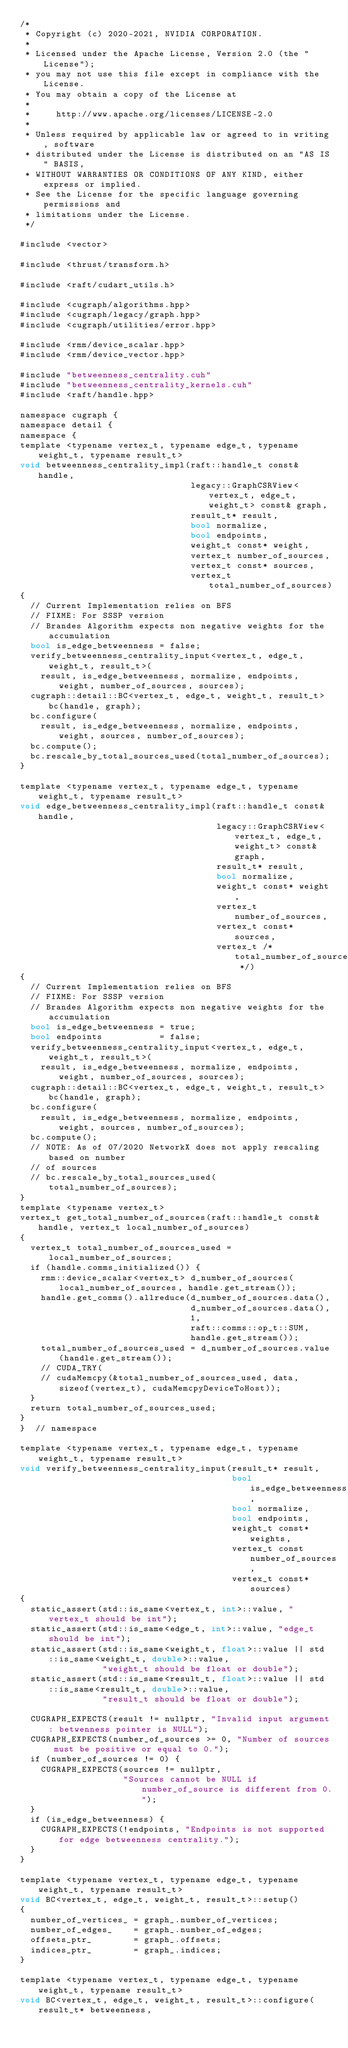Convert code to text. <code><loc_0><loc_0><loc_500><loc_500><_Cuda_>/*
 * Copyright (c) 2020-2021, NVIDIA CORPORATION.
 *
 * Licensed under the Apache License, Version 2.0 (the "License");
 * you may not use this file except in compliance with the License.
 * You may obtain a copy of the License at
 *
 *     http://www.apache.org/licenses/LICENSE-2.0
 *
 * Unless required by applicable law or agreed to in writing, software
 * distributed under the License is distributed on an "AS IS" BASIS,
 * WITHOUT WARRANTIES OR CONDITIONS OF ANY KIND, either express or implied.
 * See the License for the specific language governing permissions and
 * limitations under the License.
 */

#include <vector>

#include <thrust/transform.h>

#include <raft/cudart_utils.h>

#include <cugraph/algorithms.hpp>
#include <cugraph/legacy/graph.hpp>
#include <cugraph/utilities/error.hpp>

#include <rmm/device_scalar.hpp>
#include <rmm/device_vector.hpp>

#include "betweenness_centrality.cuh"
#include "betweenness_centrality_kernels.cuh"
#include <raft/handle.hpp>

namespace cugraph {
namespace detail {
namespace {
template <typename vertex_t, typename edge_t, typename weight_t, typename result_t>
void betweenness_centrality_impl(raft::handle_t const& handle,
                                 legacy::GraphCSRView<vertex_t, edge_t, weight_t> const& graph,
                                 result_t* result,
                                 bool normalize,
                                 bool endpoints,
                                 weight_t const* weight,
                                 vertex_t number_of_sources,
                                 vertex_t const* sources,
                                 vertex_t total_number_of_sources)
{
  // Current Implementation relies on BFS
  // FIXME: For SSSP version
  // Brandes Algorithm expects non negative weights for the accumulation
  bool is_edge_betweenness = false;
  verify_betweenness_centrality_input<vertex_t, edge_t, weight_t, result_t>(
    result, is_edge_betweenness, normalize, endpoints, weight, number_of_sources, sources);
  cugraph::detail::BC<vertex_t, edge_t, weight_t, result_t> bc(handle, graph);
  bc.configure(
    result, is_edge_betweenness, normalize, endpoints, weight, sources, number_of_sources);
  bc.compute();
  bc.rescale_by_total_sources_used(total_number_of_sources);
}

template <typename vertex_t, typename edge_t, typename weight_t, typename result_t>
void edge_betweenness_centrality_impl(raft::handle_t const& handle,
                                      legacy::GraphCSRView<vertex_t, edge_t, weight_t> const& graph,
                                      result_t* result,
                                      bool normalize,
                                      weight_t const* weight,
                                      vertex_t number_of_sources,
                                      vertex_t const* sources,
                                      vertex_t /* total_number_of_sources */)
{
  // Current Implementation relies on BFS
  // FIXME: For SSSP version
  // Brandes Algorithm expects non negative weights for the accumulation
  bool is_edge_betweenness = true;
  bool endpoints           = false;
  verify_betweenness_centrality_input<vertex_t, edge_t, weight_t, result_t>(
    result, is_edge_betweenness, normalize, endpoints, weight, number_of_sources, sources);
  cugraph::detail::BC<vertex_t, edge_t, weight_t, result_t> bc(handle, graph);
  bc.configure(
    result, is_edge_betweenness, normalize, endpoints, weight, sources, number_of_sources);
  bc.compute();
  // NOTE: As of 07/2020 NetworkX does not apply rescaling based on number
  // of sources
  // bc.rescale_by_total_sources_used(total_number_of_sources);
}
template <typename vertex_t>
vertex_t get_total_number_of_sources(raft::handle_t const& handle, vertex_t local_number_of_sources)
{
  vertex_t total_number_of_sources_used = local_number_of_sources;
  if (handle.comms_initialized()) {
    rmm::device_scalar<vertex_t> d_number_of_sources(local_number_of_sources, handle.get_stream());
    handle.get_comms().allreduce(d_number_of_sources.data(),
                                 d_number_of_sources.data(),
                                 1,
                                 raft::comms::op_t::SUM,
                                 handle.get_stream());
    total_number_of_sources_used = d_number_of_sources.value(handle.get_stream());
    // CUDA_TRY(
    // cudaMemcpy(&total_number_of_sources_used, data, sizeof(vertex_t), cudaMemcpyDeviceToHost));
  }
  return total_number_of_sources_used;
}
}  // namespace

template <typename vertex_t, typename edge_t, typename weight_t, typename result_t>
void verify_betweenness_centrality_input(result_t* result,
                                         bool is_edge_betweenness,
                                         bool normalize,
                                         bool endpoints,
                                         weight_t const* weights,
                                         vertex_t const number_of_sources,
                                         vertex_t const* sources)
{
  static_assert(std::is_same<vertex_t, int>::value, "vertex_t should be int");
  static_assert(std::is_same<edge_t, int>::value, "edge_t should be int");
  static_assert(std::is_same<weight_t, float>::value || std::is_same<weight_t, double>::value,
                "weight_t should be float or double");
  static_assert(std::is_same<result_t, float>::value || std::is_same<result_t, double>::value,
                "result_t should be float or double");

  CUGRAPH_EXPECTS(result != nullptr, "Invalid input argument: betwenness pointer is NULL");
  CUGRAPH_EXPECTS(number_of_sources >= 0, "Number of sources must be positive or equal to 0.");
  if (number_of_sources != 0) {
    CUGRAPH_EXPECTS(sources != nullptr,
                    "Sources cannot be NULL if number_of_source is different from 0.");
  }
  if (is_edge_betweenness) {
    CUGRAPH_EXPECTS(!endpoints, "Endpoints is not supported for edge betweenness centrality.");
  }
}

template <typename vertex_t, typename edge_t, typename weight_t, typename result_t>
void BC<vertex_t, edge_t, weight_t, result_t>::setup()
{
  number_of_vertices_ = graph_.number_of_vertices;
  number_of_edges_    = graph_.number_of_edges;
  offsets_ptr_        = graph_.offsets;
  indices_ptr_        = graph_.indices;
}

template <typename vertex_t, typename edge_t, typename weight_t, typename result_t>
void BC<vertex_t, edge_t, weight_t, result_t>::configure(result_t* betweenness,</code> 